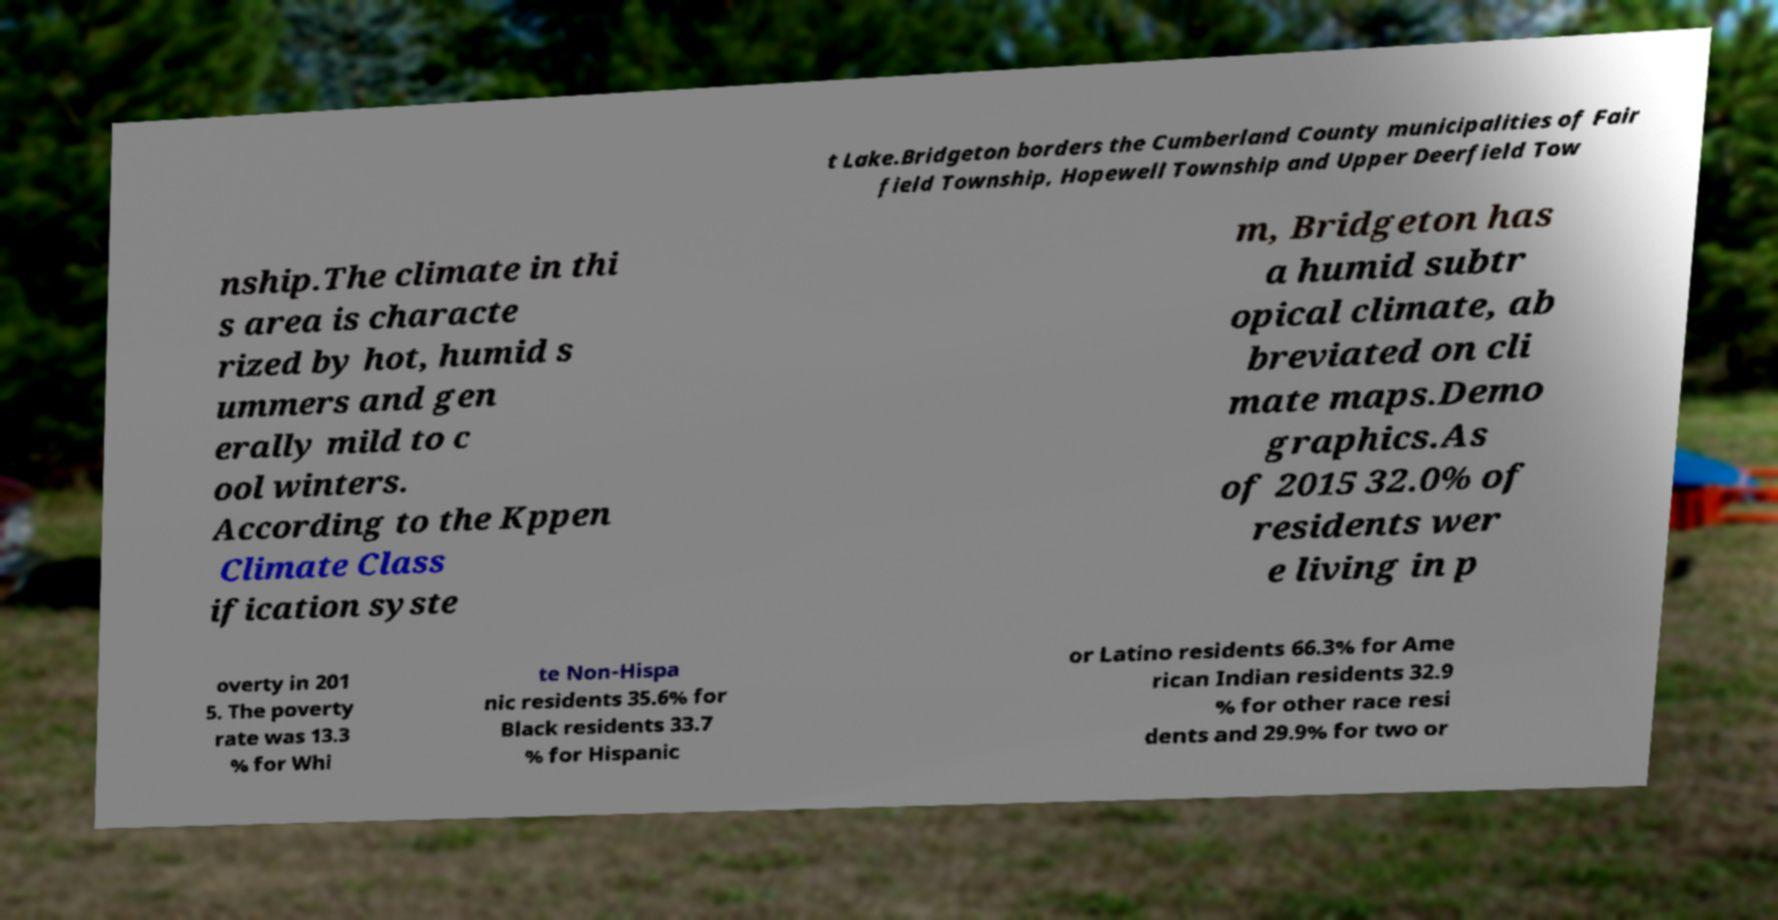Can you read and provide the text displayed in the image?This photo seems to have some interesting text. Can you extract and type it out for me? t Lake.Bridgeton borders the Cumberland County municipalities of Fair field Township, Hopewell Township and Upper Deerfield Tow nship.The climate in thi s area is characte rized by hot, humid s ummers and gen erally mild to c ool winters. According to the Kppen Climate Class ification syste m, Bridgeton has a humid subtr opical climate, ab breviated on cli mate maps.Demo graphics.As of 2015 32.0% of residents wer e living in p overty in 201 5. The poverty rate was 13.3 % for Whi te Non-Hispa nic residents 35.6% for Black residents 33.7 % for Hispanic or Latino residents 66.3% for Ame rican Indian residents 32.9 % for other race resi dents and 29.9% for two or 